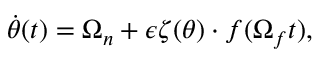Convert formula to latex. <formula><loc_0><loc_0><loc_500><loc_500>\dot { \theta } ( t ) = \Omega _ { n } + \epsilon \zeta ( \theta ) \cdot f ( \Omega _ { f } t ) ,</formula> 